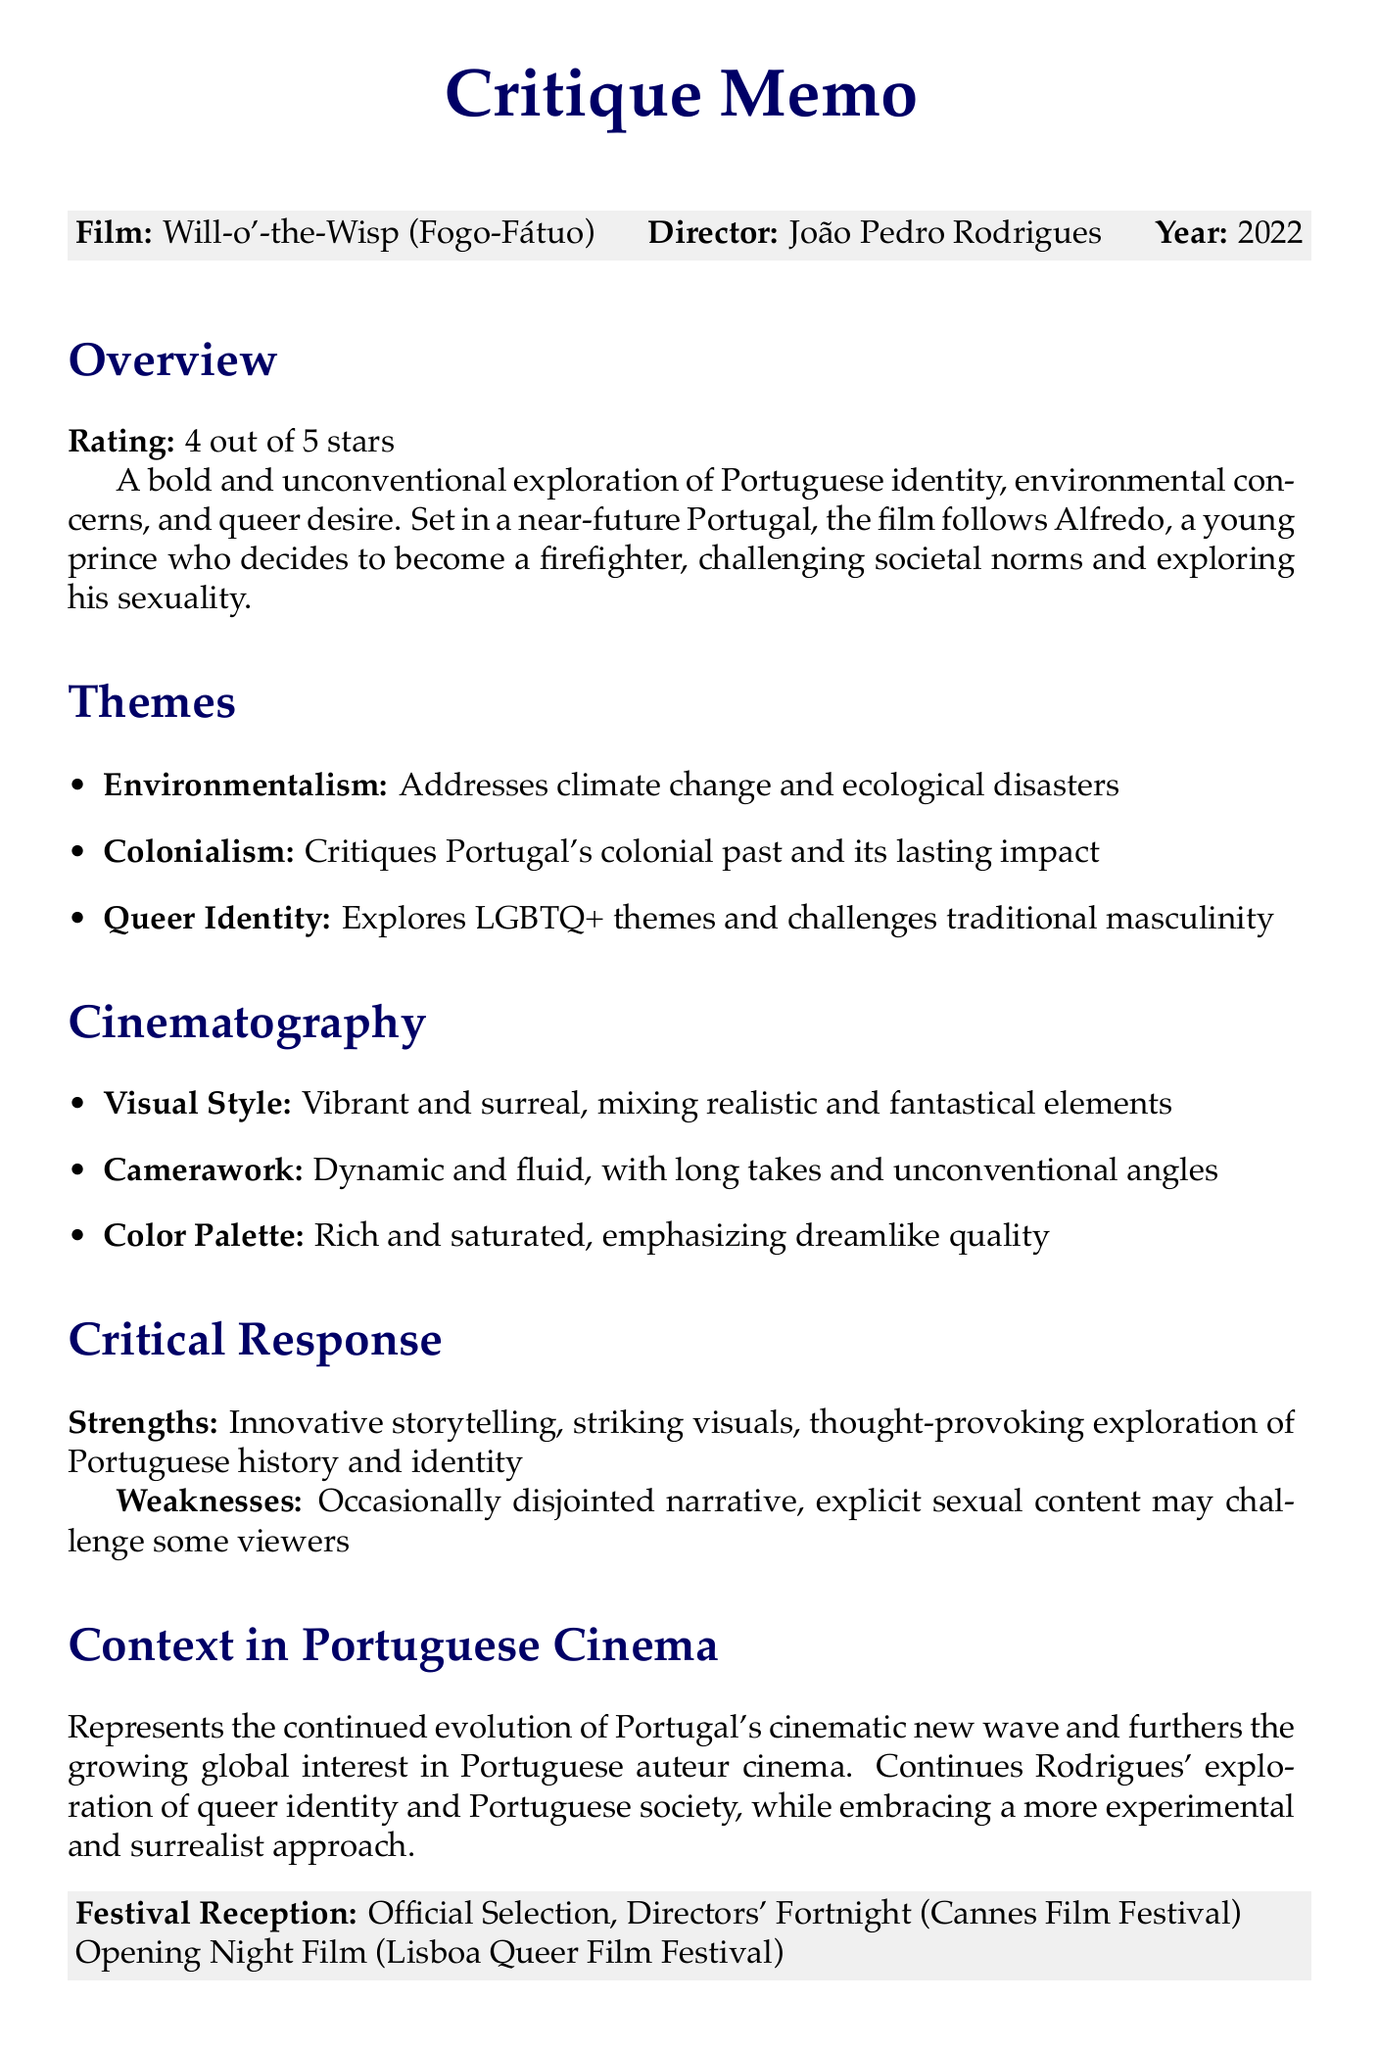what is the title of the film? The title of the film is mentioned in the document.
Answer: Will-o'-the-Wisp (Fogo-Fátuo) who is the director of the film? The director's name is provided in the document.
Answer: João Pedro Rodrigues what is the release year of the film? The release year is specifically listed in the document.
Answer: 2022 what rating did the film receive? The rating is clearly stated in the overview section of the document.
Answer: 4 out of 5 stars what themes are explored in the film? The themes are summarized in a bullet point list within the document.
Answer: Environmentalism, Colonialism, Queer Identity what is the visual style of the cinematography? The visual style is defined in the cinematography section of the document.
Answer: Vibrant and surreal how does this film relate to João Pedro Rodrigues' previous works? The document compares the themes and style with previous works by the director.
Answer: Similar themes; embraces a more experimental and surrealist approach at which festival was the film an official selection? The document lists specific festivals where the film was featured.
Answer: Cannes Film Festival what is a positive aspect mentioned in the critical response? The document lists strengths of the film in the critical response section.
Answer: Innovative storytelling approach 